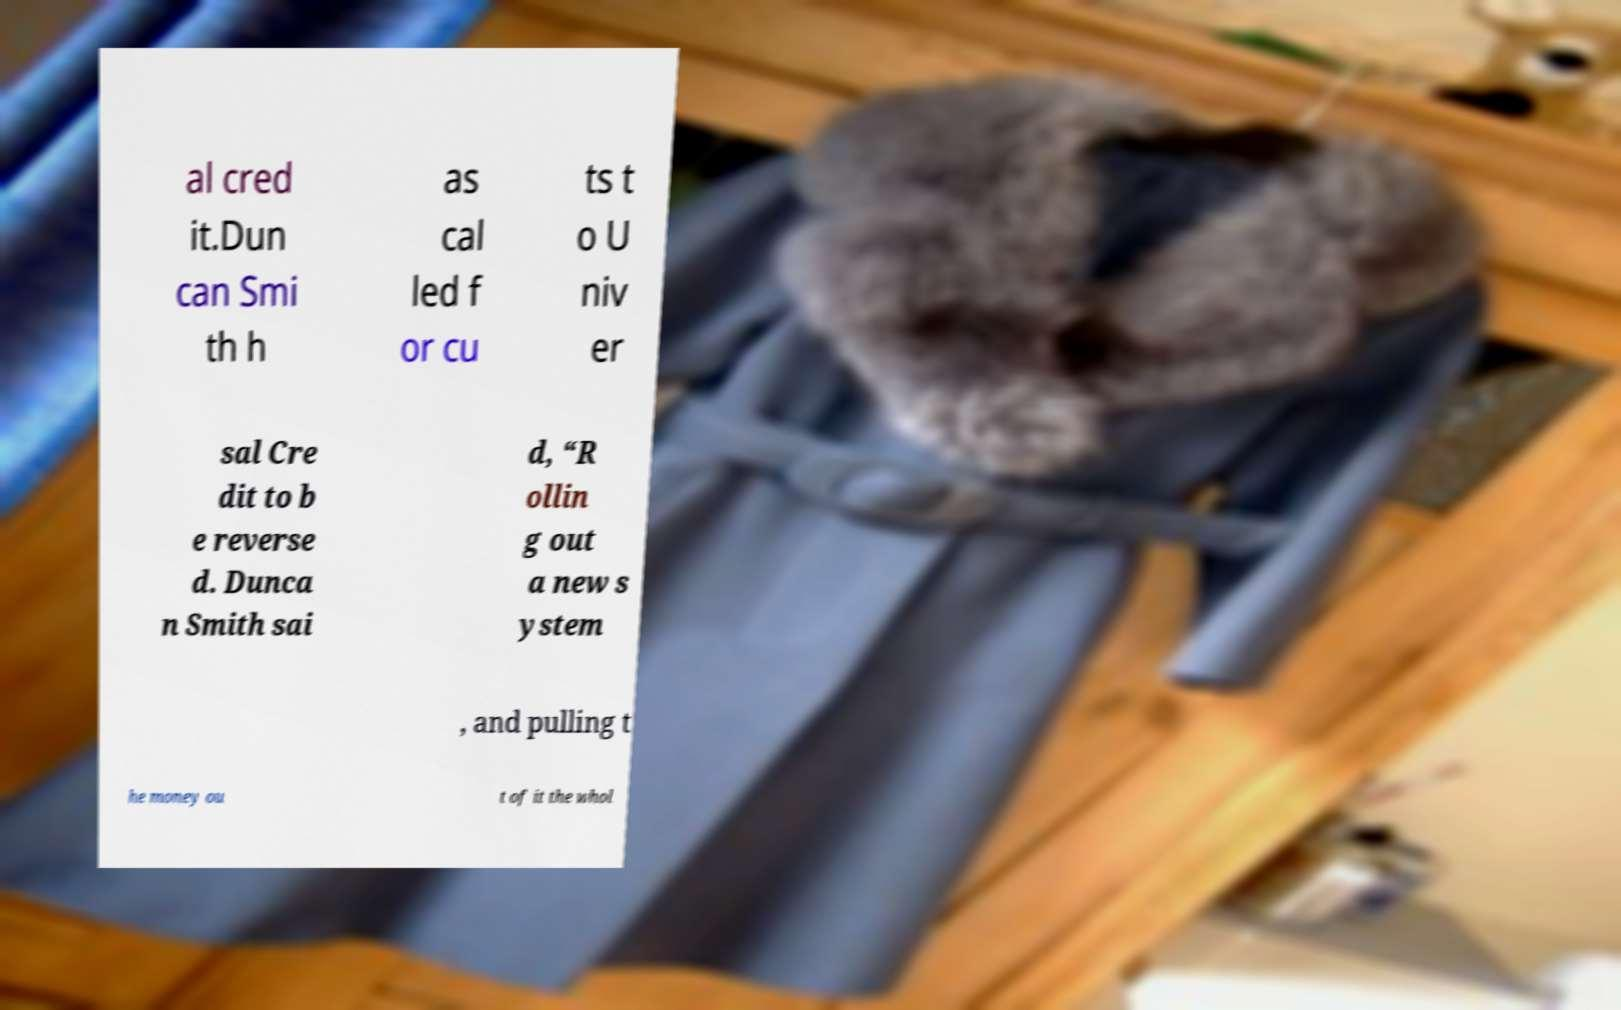Can you read and provide the text displayed in the image?This photo seems to have some interesting text. Can you extract and type it out for me? al cred it.Dun can Smi th h as cal led f or cu ts t o U niv er sal Cre dit to b e reverse d. Dunca n Smith sai d, “R ollin g out a new s ystem , and pulling t he money ou t of it the whol 